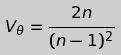Convert formula to latex. <formula><loc_0><loc_0><loc_500><loc_500>V _ { \theta } = \frac { 2 n } { ( n - 1 ) ^ { 2 } }</formula> 